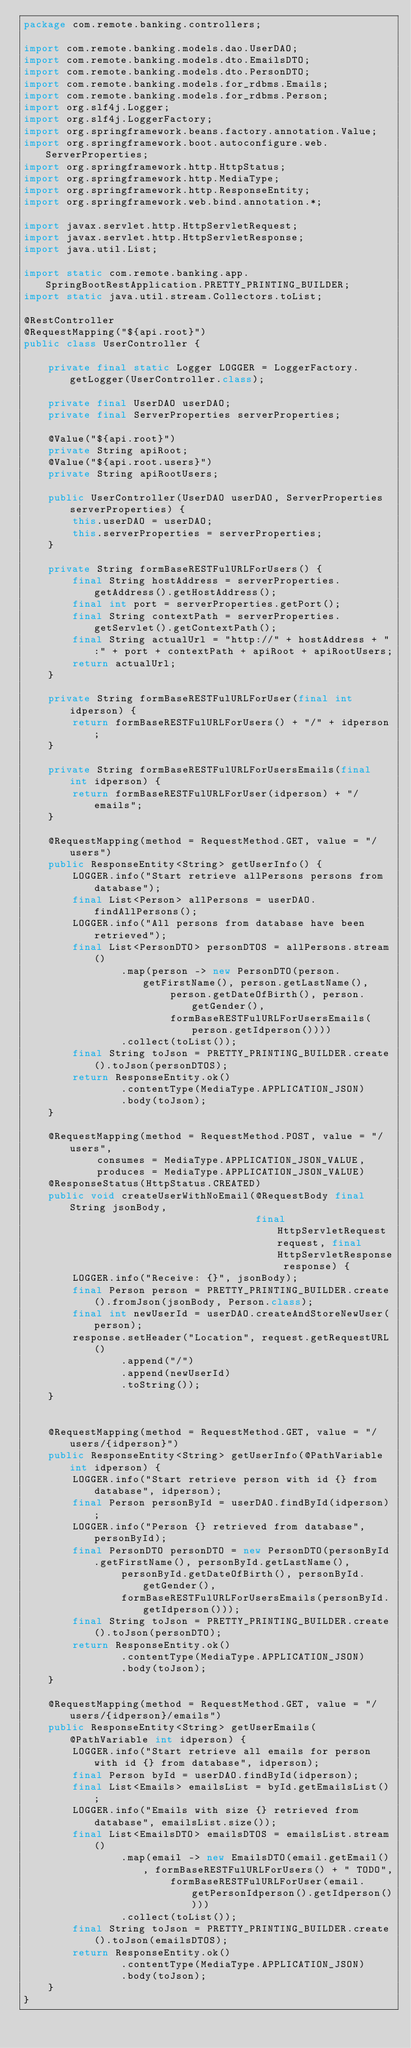Convert code to text. <code><loc_0><loc_0><loc_500><loc_500><_Java_>package com.remote.banking.controllers;

import com.remote.banking.models.dao.UserDAO;
import com.remote.banking.models.dto.EmailsDTO;
import com.remote.banking.models.dto.PersonDTO;
import com.remote.banking.models.for_rdbms.Emails;
import com.remote.banking.models.for_rdbms.Person;
import org.slf4j.Logger;
import org.slf4j.LoggerFactory;
import org.springframework.beans.factory.annotation.Value;
import org.springframework.boot.autoconfigure.web.ServerProperties;
import org.springframework.http.HttpStatus;
import org.springframework.http.MediaType;
import org.springframework.http.ResponseEntity;
import org.springframework.web.bind.annotation.*;

import javax.servlet.http.HttpServletRequest;
import javax.servlet.http.HttpServletResponse;
import java.util.List;

import static com.remote.banking.app.SpringBootRestApplication.PRETTY_PRINTING_BUILDER;
import static java.util.stream.Collectors.toList;

@RestController
@RequestMapping("${api.root}")
public class UserController {

    private final static Logger LOGGER = LoggerFactory.getLogger(UserController.class);

    private final UserDAO userDAO;
    private final ServerProperties serverProperties;

    @Value("${api.root}")
    private String apiRoot;
    @Value("${api.root.users}")
    private String apiRootUsers;

    public UserController(UserDAO userDAO, ServerProperties serverProperties) {
        this.userDAO = userDAO;
        this.serverProperties = serverProperties;
    }

    private String formBaseRESTFulURLForUsers() {
        final String hostAddress = serverProperties.getAddress().getHostAddress();
        final int port = serverProperties.getPort();
        final String contextPath = serverProperties.getServlet().getContextPath();
        final String actualUrl = "http://" + hostAddress + ":" + port + contextPath + apiRoot + apiRootUsers;
        return actualUrl;
    }

    private String formBaseRESTFulURLForUser(final int idperson) {
        return formBaseRESTFulURLForUsers() + "/" + idperson;
    }

    private String formBaseRESTFulURLForUsersEmails(final int idperson) {
        return formBaseRESTFulURLForUser(idperson) + "/emails";
    }

    @RequestMapping(method = RequestMethod.GET, value = "/users")
    public ResponseEntity<String> getUserInfo() {
        LOGGER.info("Start retrieve allPersons persons from database");
        final List<Person> allPersons = userDAO.findAllPersons();
        LOGGER.info("All persons from database have been retrieved");
        final List<PersonDTO> personDTOS = allPersons.stream()
                .map(person -> new PersonDTO(person.getFirstName(), person.getLastName(),
                        person.getDateOfBirth(), person.getGender(),
                        formBaseRESTFulURLForUsersEmails(person.getIdperson())))
                .collect(toList());
        final String toJson = PRETTY_PRINTING_BUILDER.create().toJson(personDTOS);
        return ResponseEntity.ok()
                .contentType(MediaType.APPLICATION_JSON)
                .body(toJson);
    }

    @RequestMapping(method = RequestMethod.POST, value = "/users",
            consumes = MediaType.APPLICATION_JSON_VALUE,
            produces = MediaType.APPLICATION_JSON_VALUE)
    @ResponseStatus(HttpStatus.CREATED)
    public void createUserWithNoEmail(@RequestBody final String jsonBody,
                                      final HttpServletRequest request, final HttpServletResponse response) {
        LOGGER.info("Receive: {}", jsonBody);
        final Person person = PRETTY_PRINTING_BUILDER.create().fromJson(jsonBody, Person.class);
        final int newUserId = userDAO.createAndStoreNewUser(person);
        response.setHeader("Location", request.getRequestURL()
                .append("/")
                .append(newUserId)
                .toString());
    }


    @RequestMapping(method = RequestMethod.GET, value = "/users/{idperson}")
    public ResponseEntity<String> getUserInfo(@PathVariable int idperson) {
        LOGGER.info("Start retrieve person with id {} from database", idperson);
        final Person personById = userDAO.findById(idperson);
        LOGGER.info("Person {} retrieved from database", personById);
        final PersonDTO personDTO = new PersonDTO(personById.getFirstName(), personById.getLastName(),
                personById.getDateOfBirth(), personById.getGender(),
                formBaseRESTFulURLForUsersEmails(personById.getIdperson()));
        final String toJson = PRETTY_PRINTING_BUILDER.create().toJson(personDTO);
        return ResponseEntity.ok()
                .contentType(MediaType.APPLICATION_JSON)
                .body(toJson);
    }

    @RequestMapping(method = RequestMethod.GET, value = "/users/{idperson}/emails")
    public ResponseEntity<String> getUserEmails(@PathVariable int idperson) {
        LOGGER.info("Start retrieve all emails for person with id {} from database", idperson);
        final Person byId = userDAO.findById(idperson);
        final List<Emails> emailsList = byId.getEmailsList();
        LOGGER.info("Emails with size {} retrieved from database", emailsList.size());
        final List<EmailsDTO> emailsDTOS = emailsList.stream()
                .map(email -> new EmailsDTO(email.getEmail(), formBaseRESTFulURLForUsers() + " TODO",
                        formBaseRESTFulURLForUser(email.getPersonIdperson().getIdperson())))
                .collect(toList());
        final String toJson = PRETTY_PRINTING_BUILDER.create().toJson(emailsDTOS);
        return ResponseEntity.ok()
                .contentType(MediaType.APPLICATION_JSON)
                .body(toJson);
    }
}
</code> 